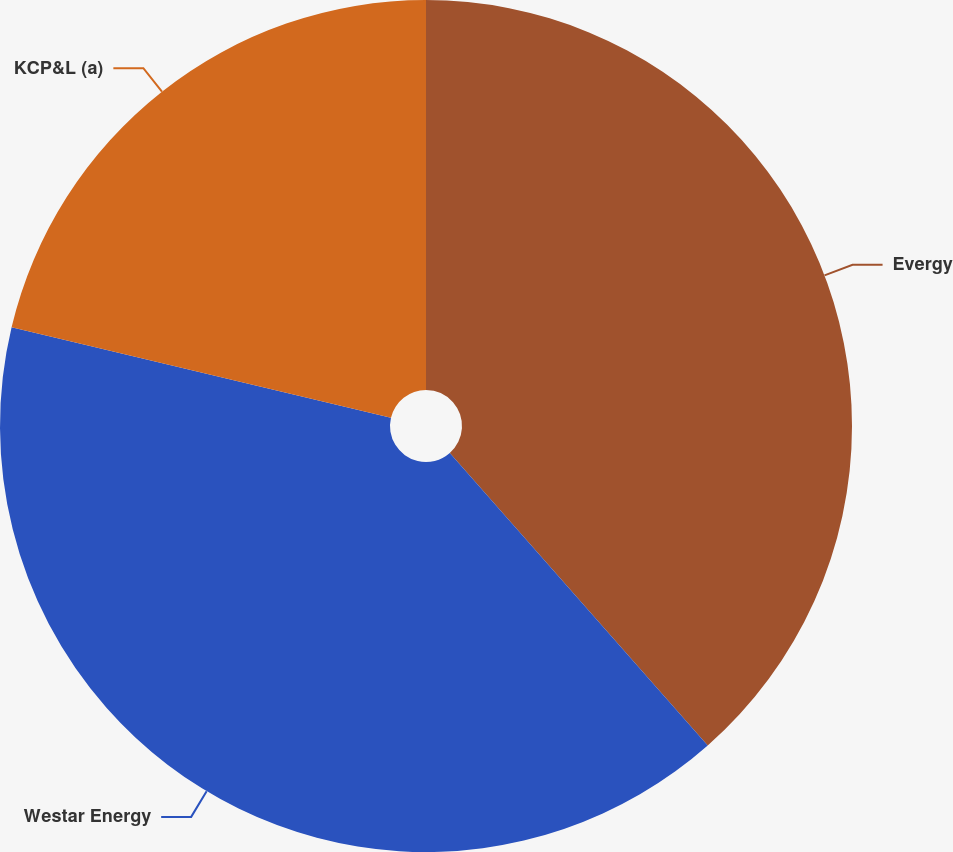Convert chart to OTSL. <chart><loc_0><loc_0><loc_500><loc_500><pie_chart><fcel>Evergy<fcel>Westar Energy<fcel>KCP&L (a)<nl><fcel>38.5%<fcel>40.22%<fcel>21.28%<nl></chart> 